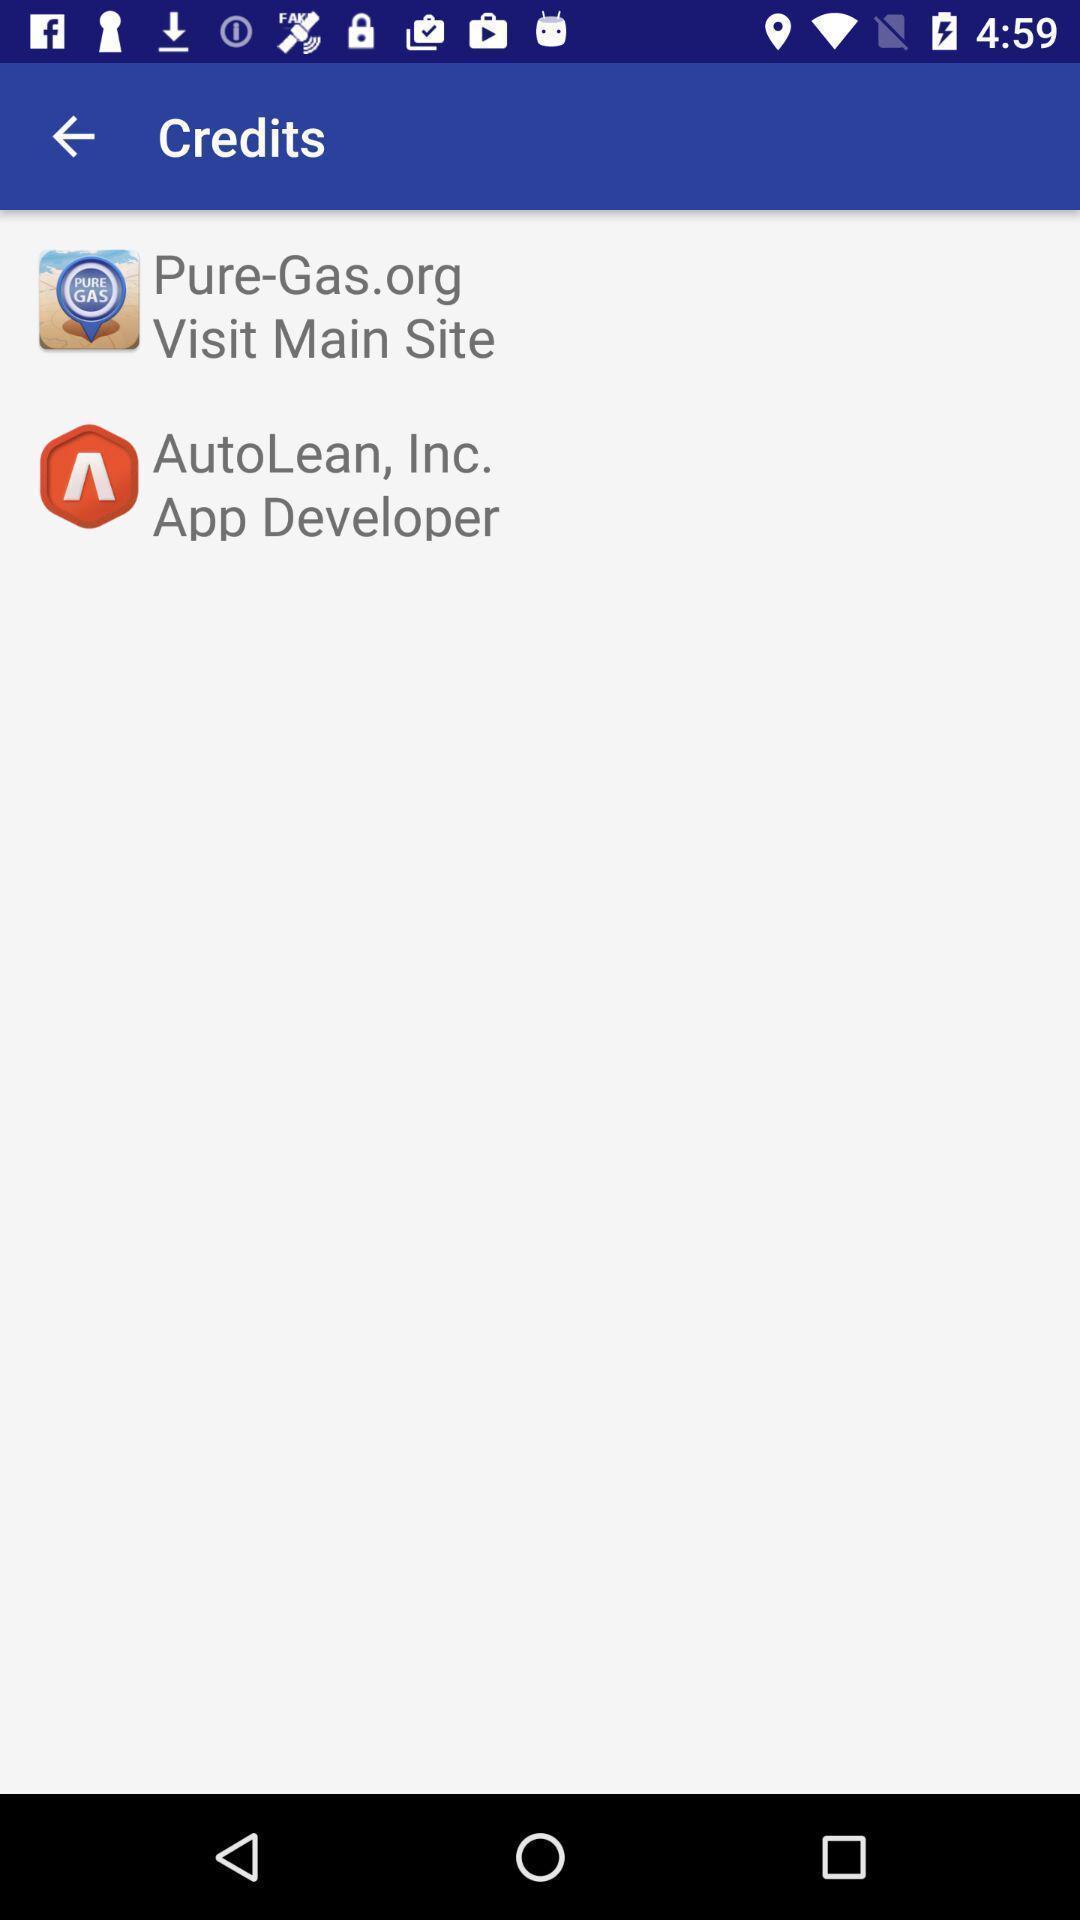Summarize the main components in this picture. Window displaying a gas app. 